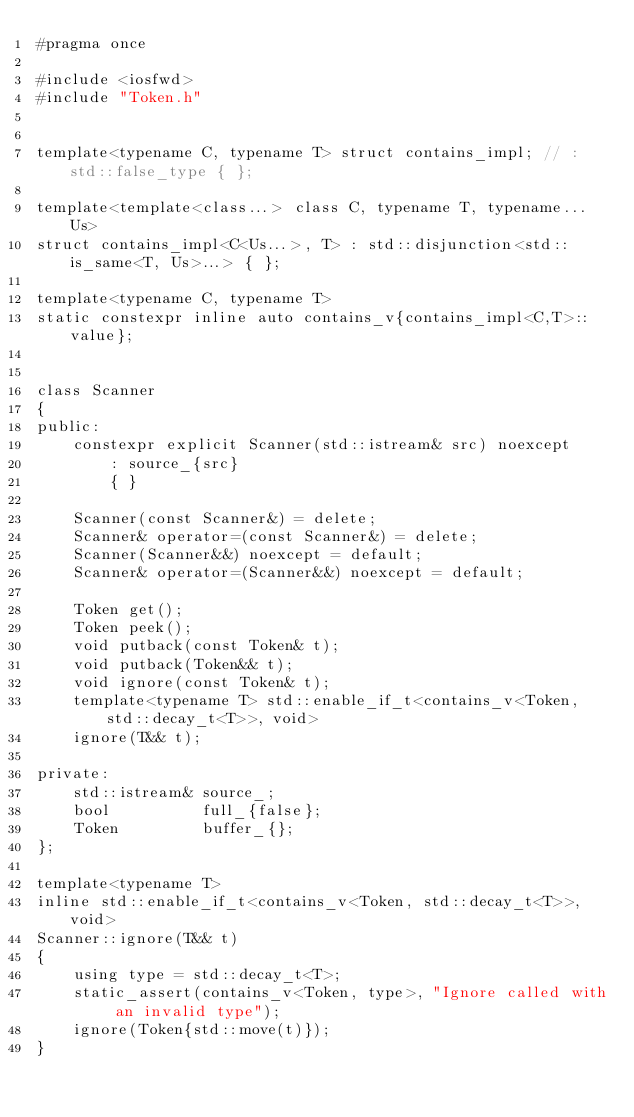Convert code to text. <code><loc_0><loc_0><loc_500><loc_500><_C_>#pragma once

#include <iosfwd>
#include "Token.h"


template<typename C, typename T> struct contains_impl; // : std::false_type { };

template<template<class...> class C, typename T, typename... Us>
struct contains_impl<C<Us...>, T> : std::disjunction<std::is_same<T, Us>...> { };

template<typename C, typename T>
static constexpr inline auto contains_v{contains_impl<C,T>::value};


class Scanner
{
public:
    constexpr explicit Scanner(std::istream& src) noexcept
        : source_{src}
        { }

    Scanner(const Scanner&) = delete;
    Scanner& operator=(const Scanner&) = delete;
    Scanner(Scanner&&) noexcept = default;
    Scanner& operator=(Scanner&&) noexcept = default;

    Token get();
    Token peek();
    void putback(const Token& t);
    void putback(Token&& t);
    void ignore(const Token& t);
    template<typename T> std::enable_if_t<contains_v<Token, std::decay_t<T>>, void>
    ignore(T&& t);

private:
    std::istream& source_;
    bool          full_{false};
    Token         buffer_{};
};

template<typename T>
inline std::enable_if_t<contains_v<Token, std::decay_t<T>>, void>
Scanner::ignore(T&& t)
{
    using type = std::decay_t<T>;
    static_assert(contains_v<Token, type>, "Ignore called with an invalid type");
    ignore(Token{std::move(t)});
}
</code> 